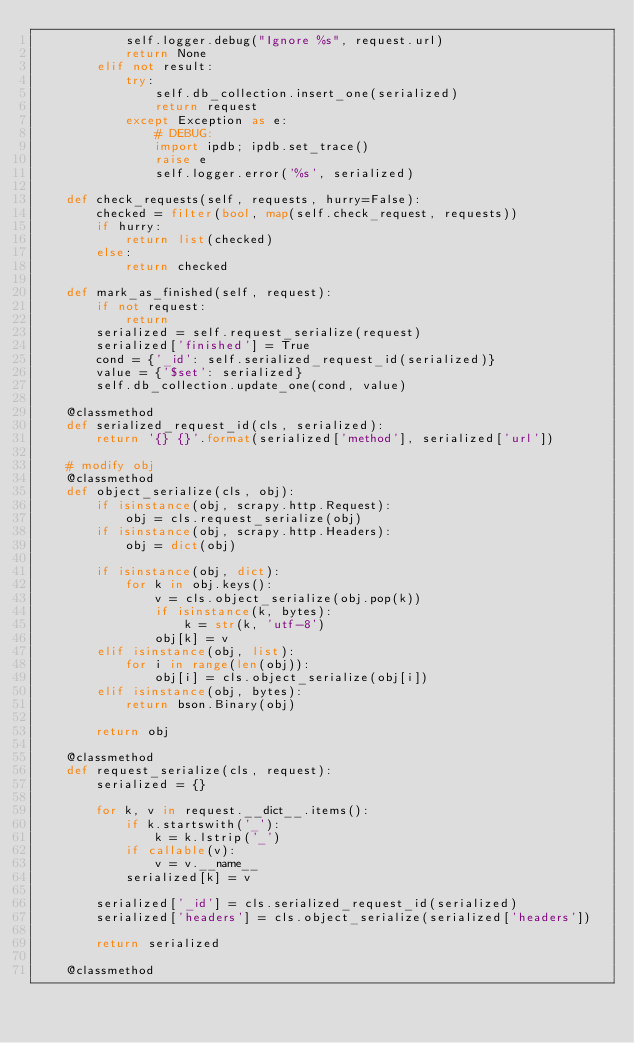Convert code to text. <code><loc_0><loc_0><loc_500><loc_500><_Python_>            self.logger.debug("Ignore %s", request.url)
            return None
        elif not result:
            try:
                self.db_collection.insert_one(serialized)
                return request
            except Exception as e:
                # DEBUG:
                import ipdb; ipdb.set_trace()
                raise e
                self.logger.error('%s', serialized)

    def check_requests(self, requests, hurry=False):
        checked = filter(bool, map(self.check_request, requests))
        if hurry:
            return list(checked)
        else:
            return checked

    def mark_as_finished(self, request):
        if not request:
            return
        serialized = self.request_serialize(request)
        serialized['finished'] = True
        cond = {'_id': self.serialized_request_id(serialized)}
        value = {'$set': serialized}
        self.db_collection.update_one(cond, value)

    @classmethod
    def serialized_request_id(cls, serialized):
        return '{} {}'.format(serialized['method'], serialized['url'])

    # modify obj
    @classmethod
    def object_serialize(cls, obj):
        if isinstance(obj, scrapy.http.Request):
            obj = cls.request_serialize(obj)
        if isinstance(obj, scrapy.http.Headers):
            obj = dict(obj)

        if isinstance(obj, dict):
            for k in obj.keys():
                v = cls.object_serialize(obj.pop(k))
                if isinstance(k, bytes):
                    k = str(k, 'utf-8')
                obj[k] = v
        elif isinstance(obj, list):
            for i in range(len(obj)):
                obj[i] = cls.object_serialize(obj[i])
        elif isinstance(obj, bytes):
            return bson.Binary(obj)

        return obj

    @classmethod
    def request_serialize(cls, request):
        serialized = {}

        for k, v in request.__dict__.items():
            if k.startswith('_'):
                k = k.lstrip('_')
            if callable(v):
                v = v.__name__
            serialized[k] = v

        serialized['_id'] = cls.serialized_request_id(serialized)
        serialized['headers'] = cls.object_serialize(serialized['headers'])

        return serialized

    @classmethod</code> 